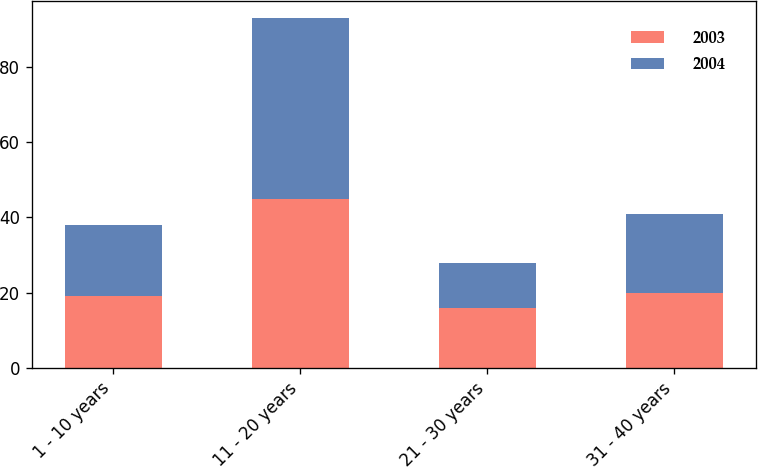Convert chart to OTSL. <chart><loc_0><loc_0><loc_500><loc_500><stacked_bar_chart><ecel><fcel>1 - 10 years<fcel>11 - 20 years<fcel>21 - 30 years<fcel>31 - 40 years<nl><fcel>2003<fcel>19<fcel>45<fcel>16<fcel>20<nl><fcel>2004<fcel>19<fcel>48<fcel>12<fcel>21<nl></chart> 